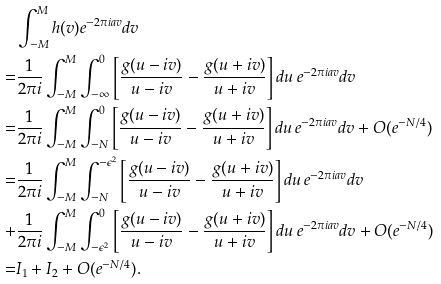<formula> <loc_0><loc_0><loc_500><loc_500>& \int _ { - M } ^ { M } h ( v ) e ^ { - 2 \pi i a v } d v \\ = & \frac { 1 } { 2 \pi i } \int _ { - M } ^ { M } \int _ { - \infty } ^ { 0 } \left [ \frac { g ( u - i v ) } { u - i v } - \frac { g ( u + i v ) } { u + i v } \right ] d u \, e ^ { - 2 \pi i a v } d v \\ = & \frac { 1 } { 2 \pi i } \int _ { - M } ^ { M } \int _ { - N } ^ { 0 } \left [ \frac { g ( u - i v ) } { u - i v } - \frac { g ( u + i v ) } { u + i v } \right ] d u \, e ^ { - 2 \pi i a v } d v + O ( e ^ { - N / 4 } ) \\ = & \frac { 1 } { 2 \pi i } \int _ { - M } ^ { M } \int _ { - N } ^ { - \epsilon ^ { 2 } } \left [ \frac { g ( u - i v ) } { u - i v } - \frac { g ( u + i v ) } { u + i v } \right ] d u \, e ^ { - 2 \pi i a v } d v \\ + & \frac { 1 } { 2 \pi i } \int _ { - M } ^ { M } \int _ { - \epsilon ^ { 2 } } ^ { 0 } \left [ \frac { g ( u - i v ) } { u - i v } - \frac { g ( u + i v ) } { u + i v } \right ] d u \, e ^ { - 2 \pi i a v } d v + O ( e ^ { - N / 4 } ) \\ = & I _ { 1 } + I _ { 2 } + O ( e ^ { - N / 4 } ) .</formula> 